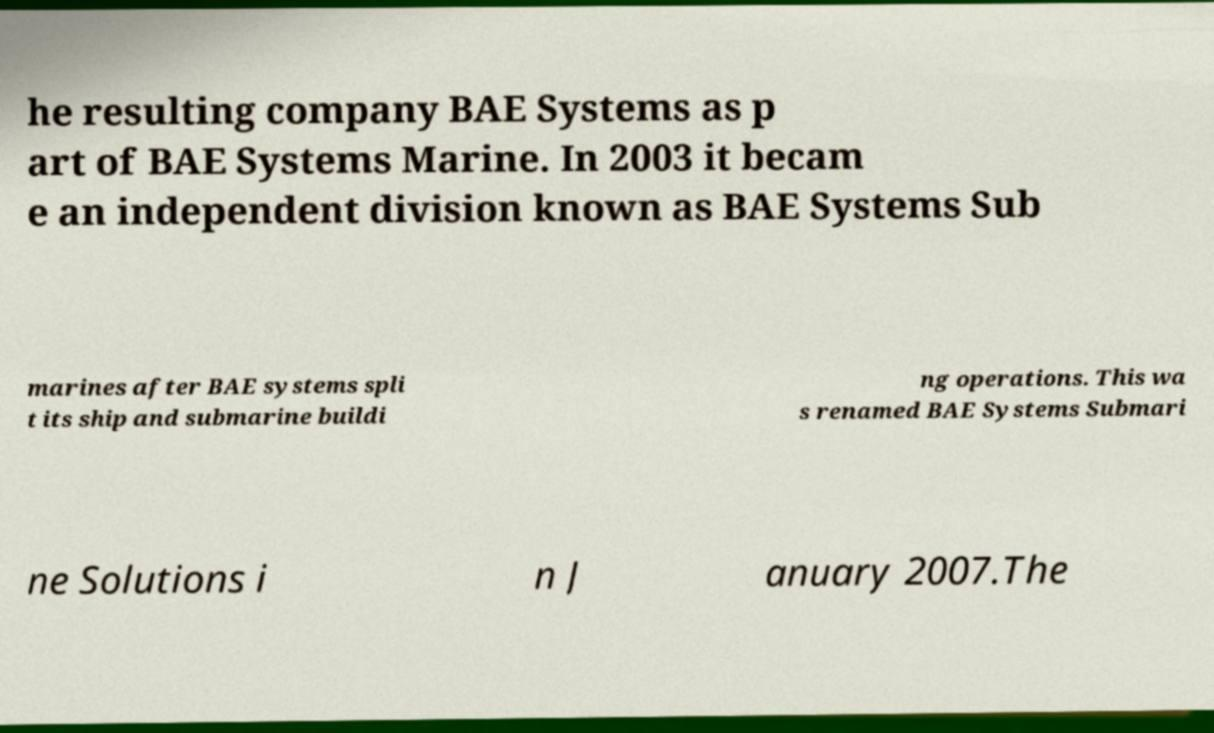Can you accurately transcribe the text from the provided image for me? he resulting company BAE Systems as p art of BAE Systems Marine. In 2003 it becam e an independent division known as BAE Systems Sub marines after BAE systems spli t its ship and submarine buildi ng operations. This wa s renamed BAE Systems Submari ne Solutions i n J anuary 2007.The 